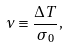<formula> <loc_0><loc_0><loc_500><loc_500>\nu \equiv \frac { \Delta T } { \sigma _ { 0 } } ,</formula> 